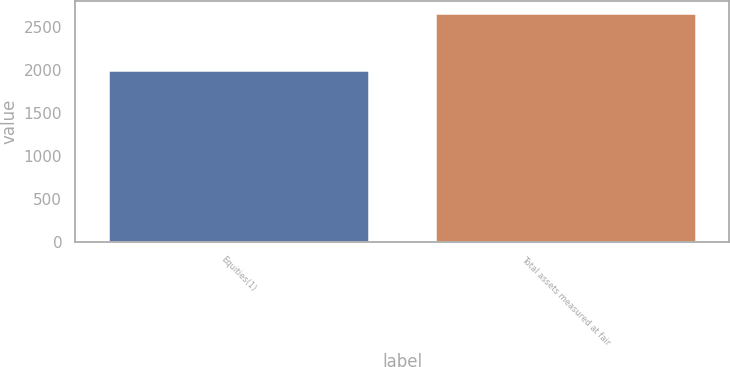Convert chart. <chart><loc_0><loc_0><loc_500><loc_500><bar_chart><fcel>Equities(1)<fcel>Total assets measured at fair<nl><fcel>2003<fcel>2666<nl></chart> 